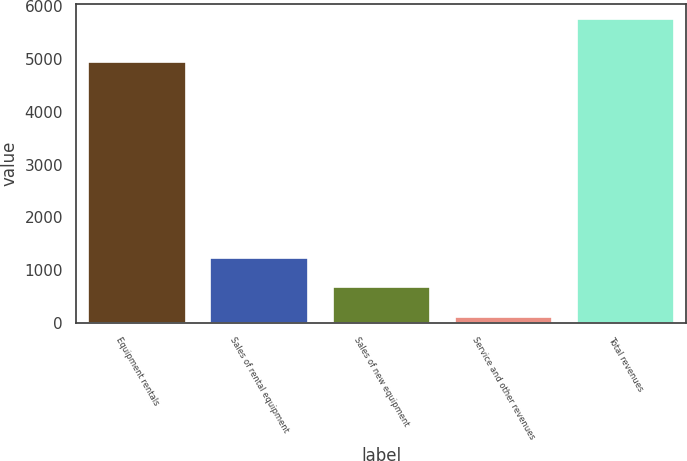Convert chart. <chart><loc_0><loc_0><loc_500><loc_500><bar_chart><fcel>Equipment rentals<fcel>Sales of rental equipment<fcel>Sales of new equipment<fcel>Service and other revenues<fcel>Total revenues<nl><fcel>4941<fcel>1234<fcel>668<fcel>102<fcel>5762<nl></chart> 